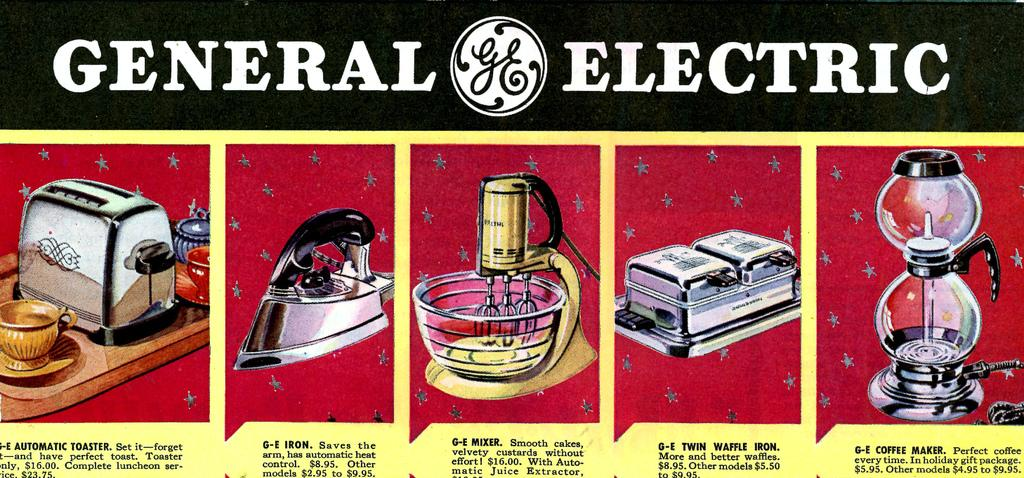<image>
Describe the image concisely. An old General Electric ad features an iron, a waffle iron, and a toaster. 